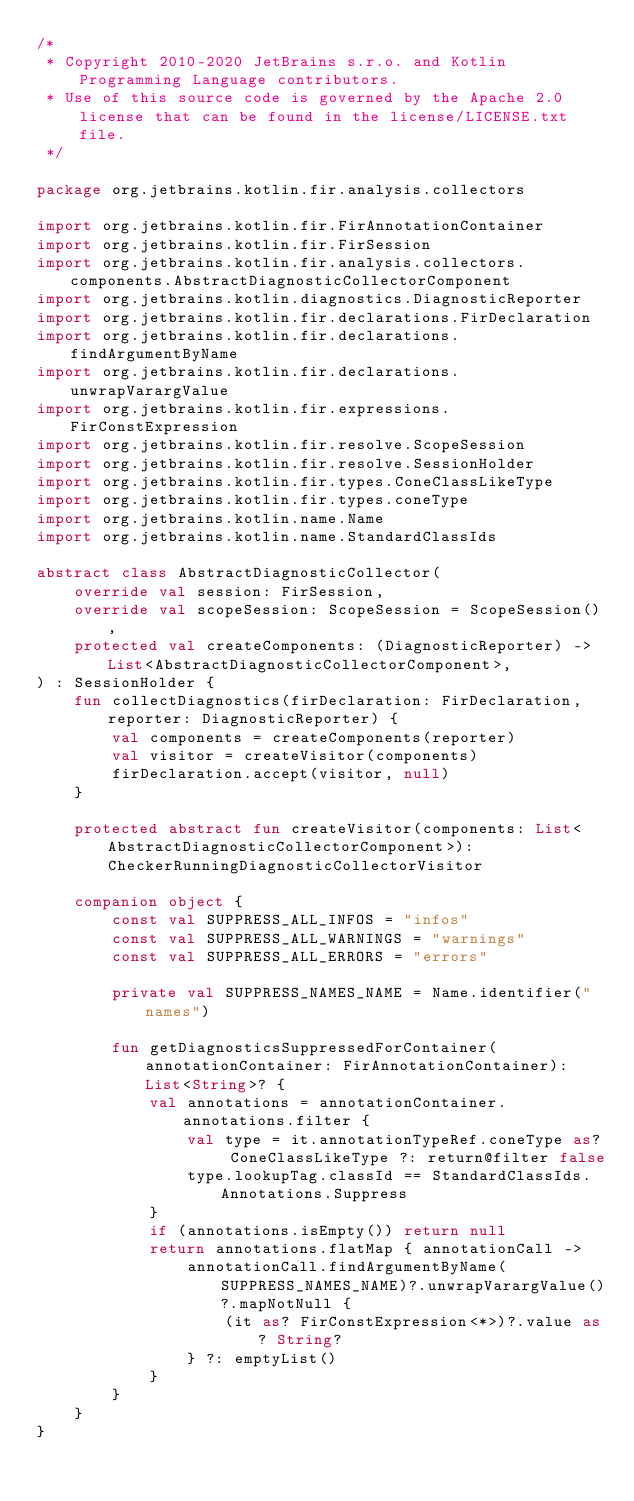Convert code to text. <code><loc_0><loc_0><loc_500><loc_500><_Kotlin_>/*
 * Copyright 2010-2020 JetBrains s.r.o. and Kotlin Programming Language contributors.
 * Use of this source code is governed by the Apache 2.0 license that can be found in the license/LICENSE.txt file.
 */

package org.jetbrains.kotlin.fir.analysis.collectors

import org.jetbrains.kotlin.fir.FirAnnotationContainer
import org.jetbrains.kotlin.fir.FirSession
import org.jetbrains.kotlin.fir.analysis.collectors.components.AbstractDiagnosticCollectorComponent
import org.jetbrains.kotlin.diagnostics.DiagnosticReporter
import org.jetbrains.kotlin.fir.declarations.FirDeclaration
import org.jetbrains.kotlin.fir.declarations.findArgumentByName
import org.jetbrains.kotlin.fir.declarations.unwrapVarargValue
import org.jetbrains.kotlin.fir.expressions.FirConstExpression
import org.jetbrains.kotlin.fir.resolve.ScopeSession
import org.jetbrains.kotlin.fir.resolve.SessionHolder
import org.jetbrains.kotlin.fir.types.ConeClassLikeType
import org.jetbrains.kotlin.fir.types.coneType
import org.jetbrains.kotlin.name.Name
import org.jetbrains.kotlin.name.StandardClassIds

abstract class AbstractDiagnosticCollector(
    override val session: FirSession,
    override val scopeSession: ScopeSession = ScopeSession(),
    protected val createComponents: (DiagnosticReporter) -> List<AbstractDiagnosticCollectorComponent>,
) : SessionHolder {
    fun collectDiagnostics(firDeclaration: FirDeclaration, reporter: DiagnosticReporter) {
        val components = createComponents(reporter)
        val visitor = createVisitor(components)
        firDeclaration.accept(visitor, null)
    }

    protected abstract fun createVisitor(components: List<AbstractDiagnosticCollectorComponent>): CheckerRunningDiagnosticCollectorVisitor

    companion object {
        const val SUPPRESS_ALL_INFOS = "infos"
        const val SUPPRESS_ALL_WARNINGS = "warnings"
        const val SUPPRESS_ALL_ERRORS = "errors"

        private val SUPPRESS_NAMES_NAME = Name.identifier("names")

        fun getDiagnosticsSuppressedForContainer(annotationContainer: FirAnnotationContainer): List<String>? {
            val annotations = annotationContainer.annotations.filter {
                val type = it.annotationTypeRef.coneType as? ConeClassLikeType ?: return@filter false
                type.lookupTag.classId == StandardClassIds.Annotations.Suppress
            }
            if (annotations.isEmpty()) return null
            return annotations.flatMap { annotationCall ->
                annotationCall.findArgumentByName(SUPPRESS_NAMES_NAME)?.unwrapVarargValue()?.mapNotNull {
                    (it as? FirConstExpression<*>)?.value as? String?
                } ?: emptyList()
            }
        }
    }
}
</code> 